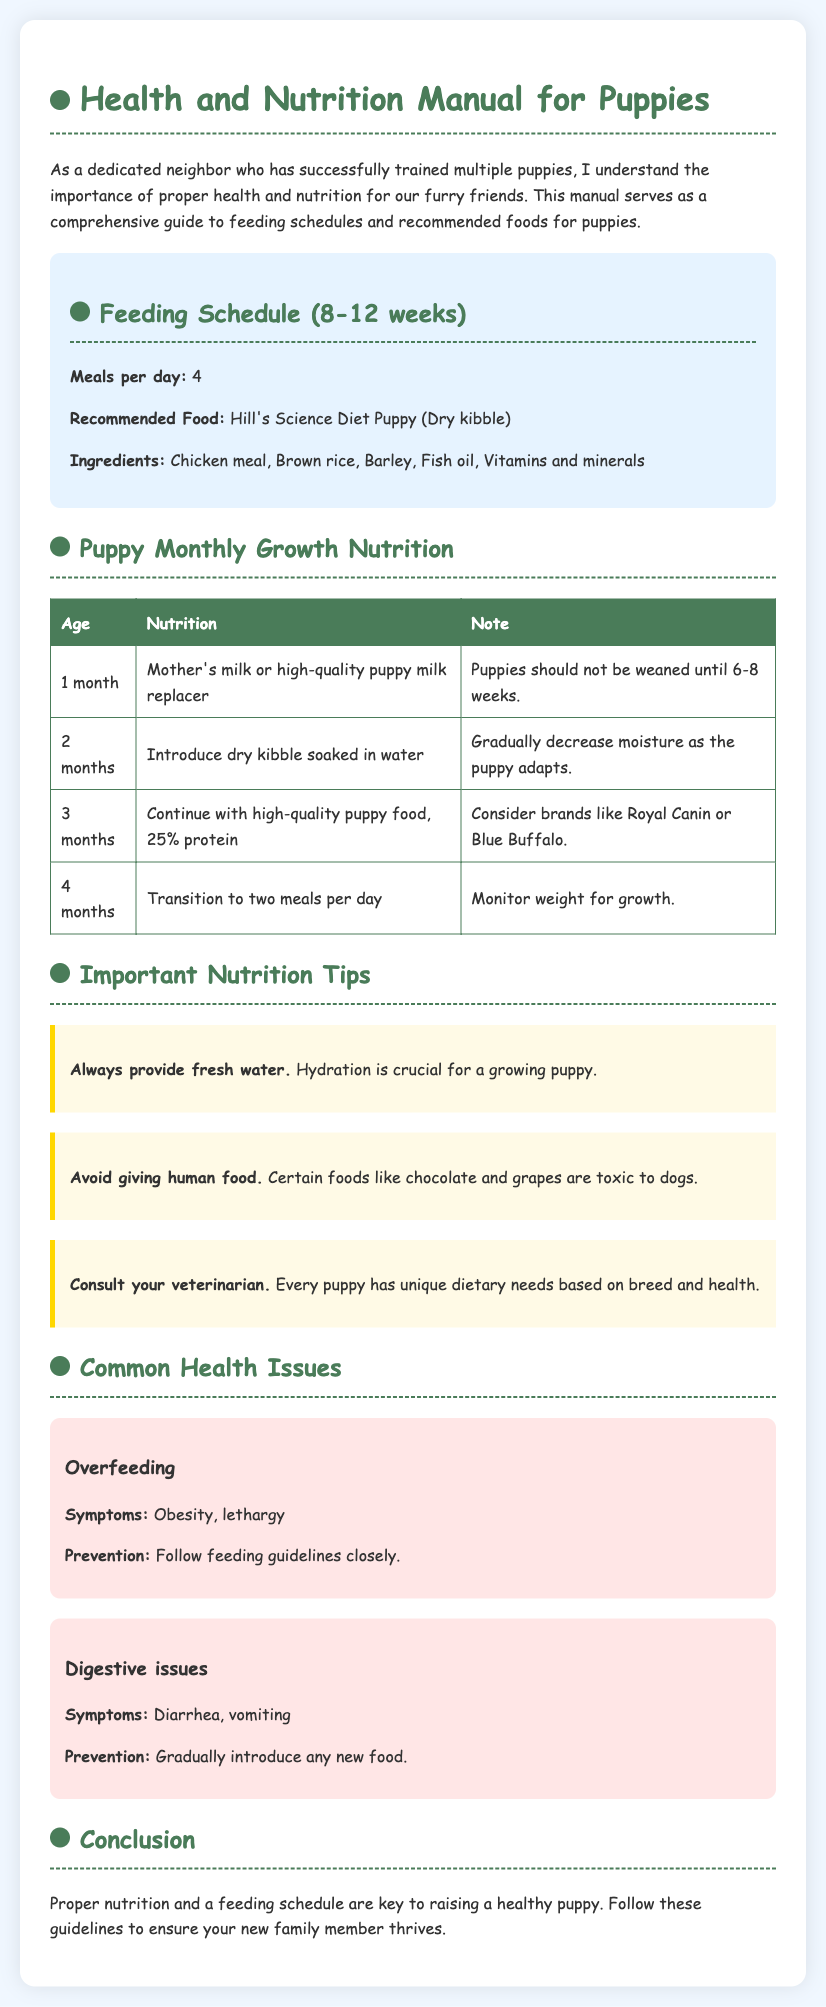What is the recommended food for puppies aged 8-12 weeks? The document specifies that the recommended food is Hill's Science Diet Puppy (Dry kibble).
Answer: Hill's Science Diet Puppy (Dry kibble) How many meals should a puppy have per day at 8-12 weeks? The feeding schedule indicates that puppies should have 4 meals per day during this age.
Answer: 4 What is a common symptom of overfeeding in puppies? The document states that a common symptom of overfeeding is obesity.
Answer: Obesity At what age should puppies start to transition to two meals per day? According to the nutrition table, puppies should transition to two meals per day at 4 months.
Answer: 4 months What type of milk should a puppy receive at 1 month old? The document indicates that puppies should receive mother's milk or high-quality puppy milk replacer at this age.
Answer: Mother's milk or high-quality puppy milk replacer What is the guideline regarding human food for puppies? The manual advises to avoid giving human food as certain foods are toxic to dogs.
Answer: Avoid giving human food What is a key prevention method for digestive issues in puppies? To prevent digestive issues, the document suggests gradually introducing any new food.
Answer: Gradually introduce any new food What should you always provide to a growing puppy according to the tips? The nutrition tips emphasize that you should always provide fresh water to ensure hydration.
Answer: Fresh water 